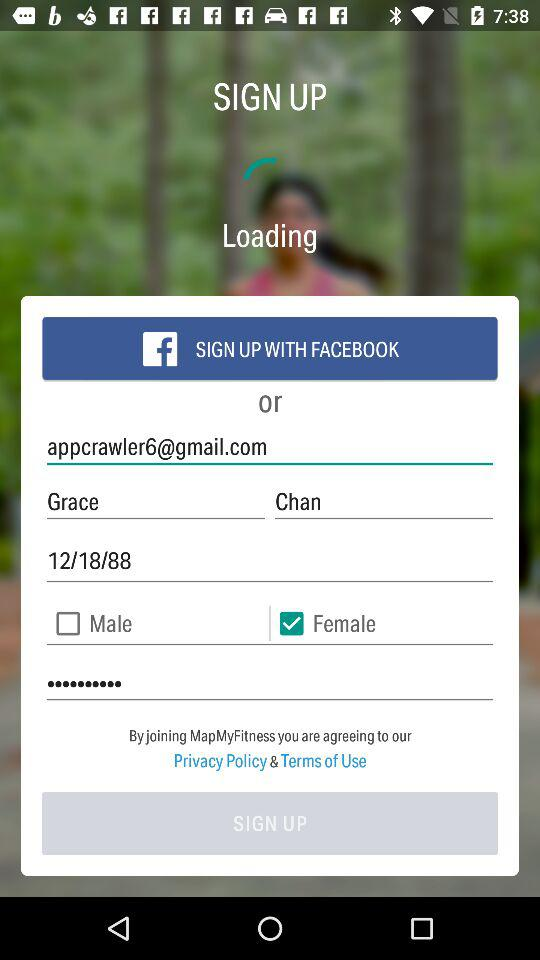What is the email address? The email address is appcrawler6@gmail.com. 